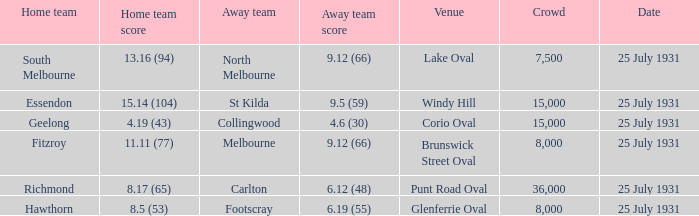When the home team was fitzroy, what did the away team score? 9.12 (66). 